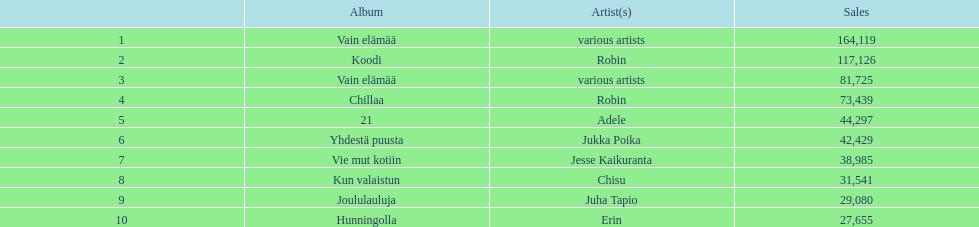What was the top selling album in this year? Vain elämää. 